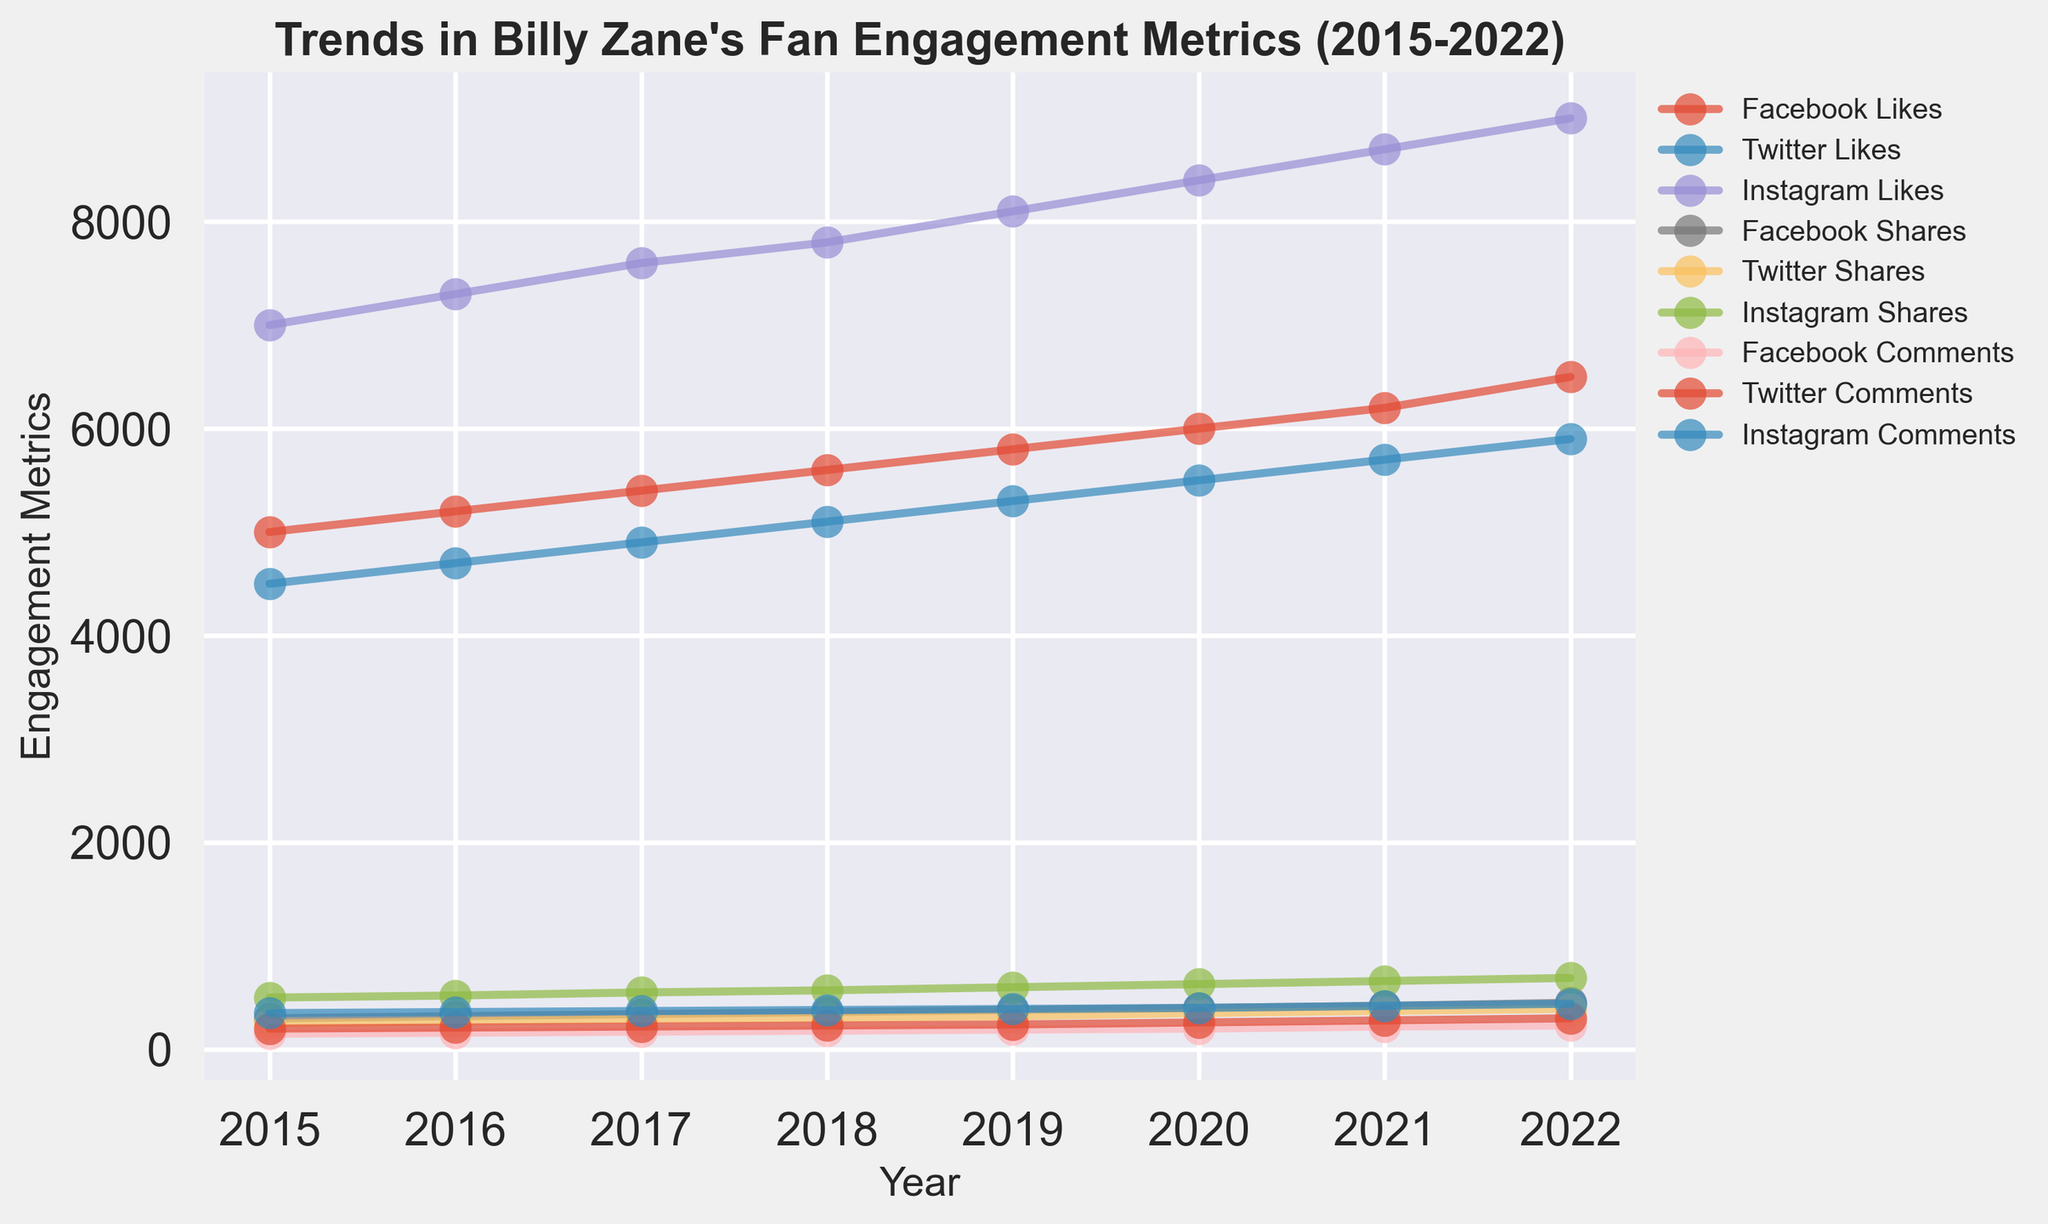What's the trend in the number of Likes for Billy Zane on Instagram from 2015 to 2022? To determine the trend, observe the line representing "Instagram Likes" over the years. From 2015 to 2022, the number of Likes on Instagram consistently increases, showing a positive trend.
Answer: Increasing Which platform had the highest number of Shares in 2020? Look at the 2020 data points for Shares across all platforms. Instagram shows the highest value for Shares in 2020.
Answer: Instagram In which year did Facebook receive the highest number of Comments? Identify the data points corresponding to "Facebook Comments" across all years. Facebook received the highest number of Comments in 2022.
Answer: 2022 By how much did the number of Likes on Twitter increase from 2019 to 2021? Subtract the number of Likes in 2019 (5300) from the number in 2021 (5700). This yields 5700 - 5300.
Answer: 400 Compare the number of comments received by Billy Zane on Facebook and Twitter in 2021. Which one is higher? Look at the 2021 data points for Comments on both platforms. Facebook had 220 Comments and Twitter had 280 Comments in 2021. Twitter had more comments.
Answer: Twitter What is the average number of Shares on Instagram from 2015 to 2022? Sum the number of Shares on Instagram from 2015 to 2022 and divide by the number of years (8): (500 + 520 + 550 + 570 + 600 + 630 + 660 + 690) / 8 = 4720 / 8
Answer: 590 